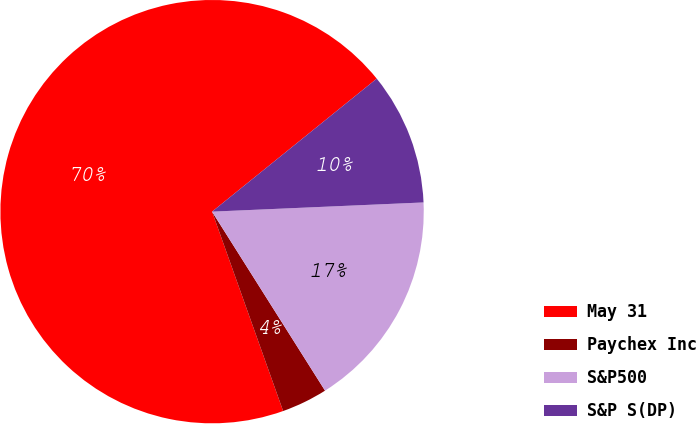Convert chart to OTSL. <chart><loc_0><loc_0><loc_500><loc_500><pie_chart><fcel>May 31<fcel>Paychex Inc<fcel>S&P500<fcel>S&P S(DP)<nl><fcel>69.63%<fcel>3.51%<fcel>16.73%<fcel>10.12%<nl></chart> 